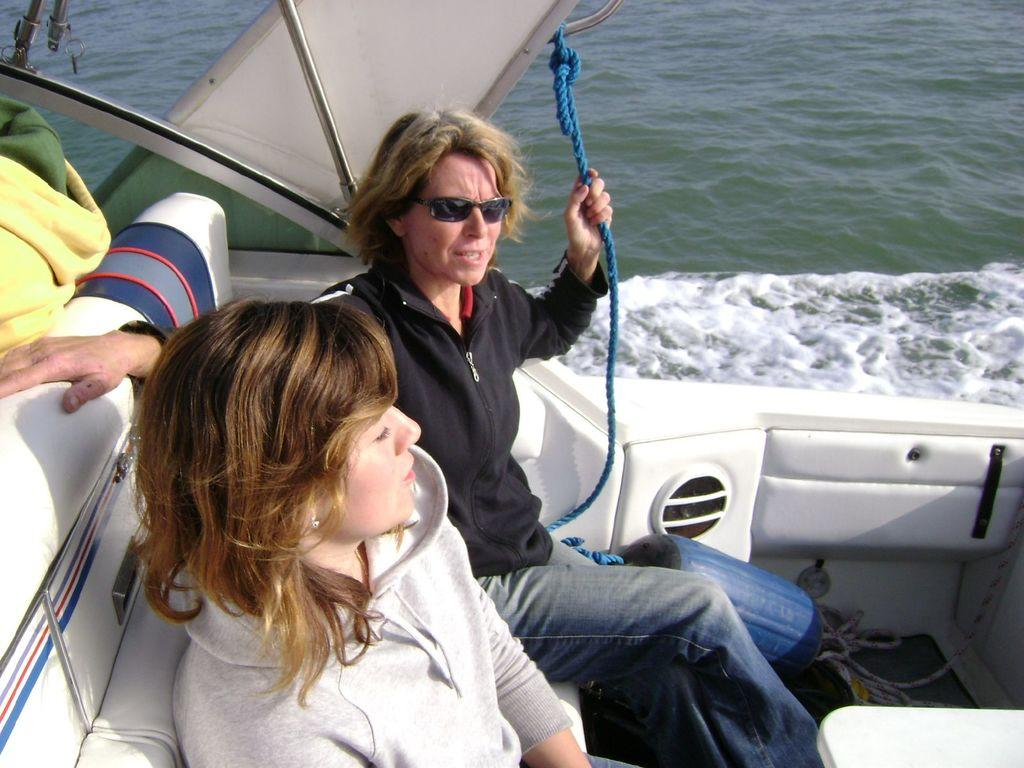How many people are in the image? There are two women in the image. What are the women doing in the image? The women are sitting in a boat. Can you describe one of the women's appearance? One of the women is wearing spectacles. What can be seen in the background of the image? There is water visible in the background of the image. What type of fruit is being served in the lunchroom in the image? There is no lunchroom or fruit present in the image; it features two women sitting in a boat. What kind of lumber is visible in the image? There is no lumber present in the image. 